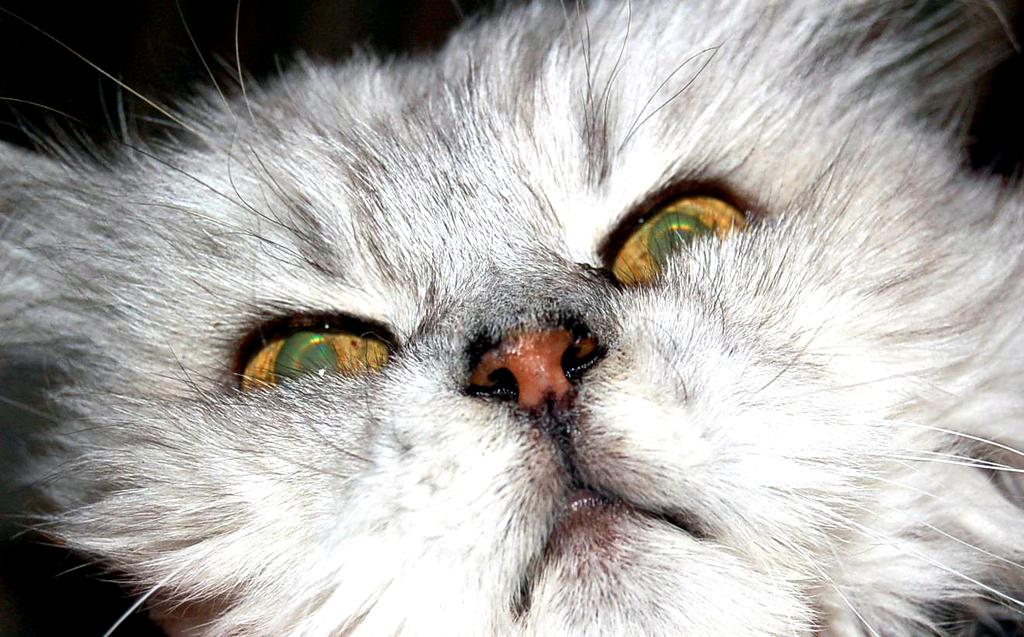What type of animal is in the image? There is a white color cat in the image. What can be observed about the background of the image? The background of the image is dark. What type of creature is holding the stick in the image? There is no creature or stick present in the image; it only features a white color cat. 